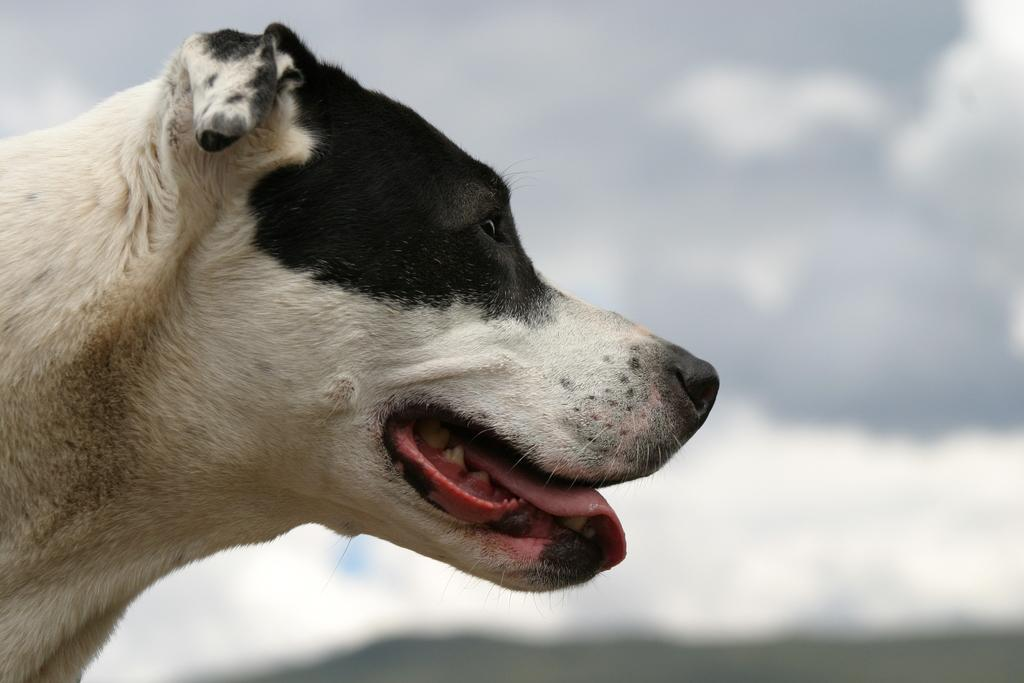What type of animal is in the image? There is a dog in the image. Can you describe the color of the dog? The dog is white and black in color. What can be observed about the background of the image? The background of the image is blurred. What type of stamp can be seen on the dog's collar in the image? There is no stamp or collar visible on the dog in the image. 